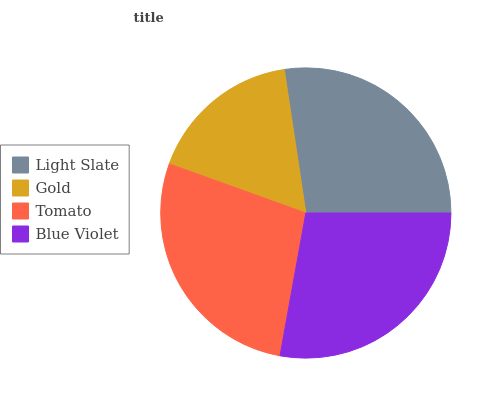Is Gold the minimum?
Answer yes or no. Yes. Is Blue Violet the maximum?
Answer yes or no. Yes. Is Tomato the minimum?
Answer yes or no. No. Is Tomato the maximum?
Answer yes or no. No. Is Tomato greater than Gold?
Answer yes or no. Yes. Is Gold less than Tomato?
Answer yes or no. Yes. Is Gold greater than Tomato?
Answer yes or no. No. Is Tomato less than Gold?
Answer yes or no. No. Is Tomato the high median?
Answer yes or no. Yes. Is Light Slate the low median?
Answer yes or no. Yes. Is Light Slate the high median?
Answer yes or no. No. Is Gold the low median?
Answer yes or no. No. 